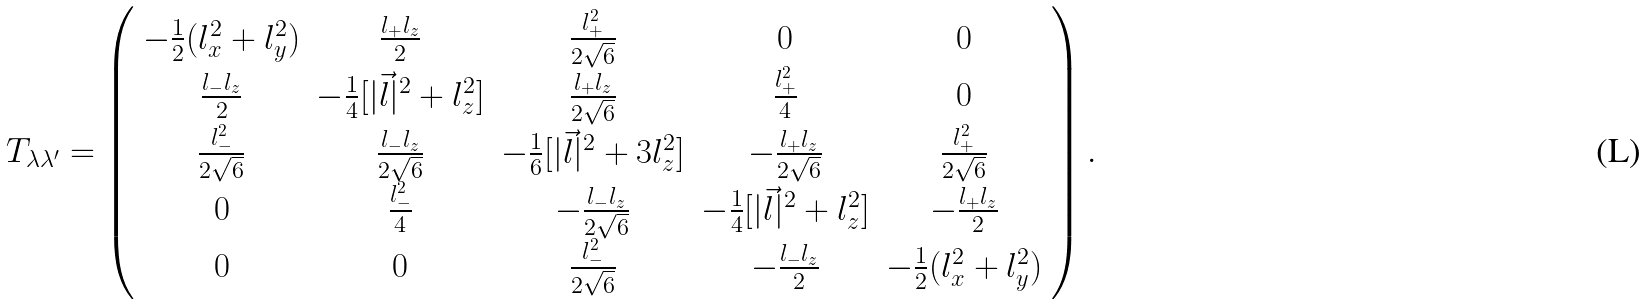Convert formula to latex. <formula><loc_0><loc_0><loc_500><loc_500>T _ { \lambda \lambda ^ { \prime } } = \left ( \begin{array} { c c c c c } { { - \frac { 1 } { 2 } ( l _ { x } ^ { 2 } + l _ { y } ^ { 2 } ) } } & { { \frac { l _ { + } l _ { z } } { 2 } } } & { { \frac { l _ { + } ^ { 2 } } { 2 \sqrt { 6 } } } } & { 0 } & { 0 } \\ { { \frac { l _ { - } l _ { z } } { 2 } } } & { { - \frac { 1 } { 4 } [ | \vec { l } | ^ { 2 } + l _ { z } ^ { 2 } ] } } & { { \frac { l _ { + } l _ { z } } { 2 \sqrt { 6 } } } } & { { \frac { l _ { + } ^ { 2 } } { 4 } } } & { 0 } \\ { { \frac { l _ { - } ^ { 2 } } { 2 \sqrt { 6 } } } } & { { \frac { l _ { - } l _ { z } } { 2 \sqrt { 6 } } } } & { { - \frac { 1 } { 6 } [ | \vec { l } | ^ { 2 } + 3 l _ { z } ^ { 2 } ] } } & { { - \frac { l _ { + } l _ { z } } { 2 \sqrt { 6 } } } } & { { \frac { l _ { + } ^ { 2 } } { 2 \sqrt { 6 } } } } \\ { 0 } & { { \frac { l _ { - } ^ { 2 } } { 4 } } } & { { - \frac { l _ { - } l _ { z } } { 2 \sqrt { 6 } } } } & { { - \frac { 1 } { 4 } [ | \vec { l } | ^ { 2 } + l _ { z } ^ { 2 } ] } } & { { - \frac { l _ { + } l _ { z } } { 2 } } } \\ { 0 } & { 0 } & { { \frac { l _ { - } ^ { 2 } } { 2 \sqrt { 6 } } } } & { { - \frac { l _ { - } l _ { z } } { 2 } } } & { { - \frac { 1 } { 2 } ( l _ { x } ^ { 2 } + l _ { y } ^ { 2 } ) } } \end{array} \right ) .</formula> 